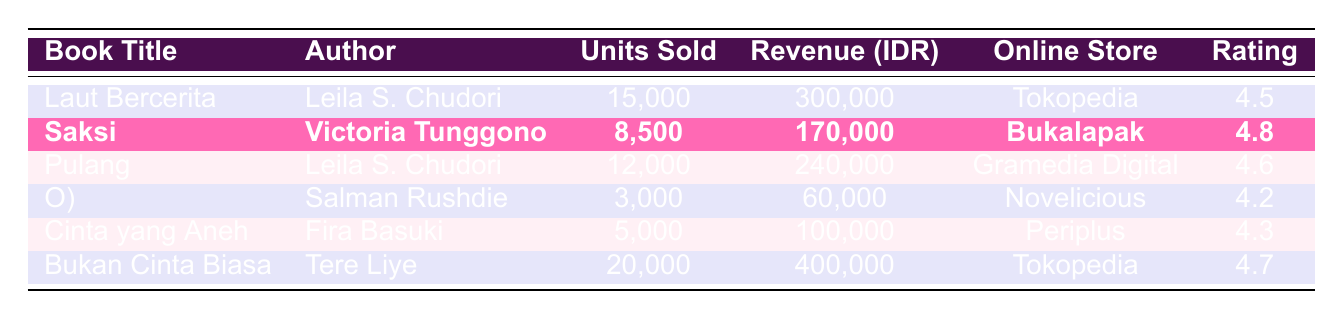What is the total revenue generated from all books listed in the table? To find the total revenue, sum the revenue amounts: 300,000 + 170,000 + 240,000 + 60,000 + 100,000 + 400,000 = 1,360,000.
Answer: 1,360,000 Which book sold the highest number of units? Compare the units sold for each book: Laut Bercerita (15,000), Saksi (8,500), Pulang (12,000), O) (3,000), Cinta yang Aneh (5,000), and Bukan Cinta Biasa (20,000). Bukan Cinta Biasa has the highest units sold at 20,000.
Answer: Bukan Cinta Biasa What is the average rating of the books listed? Calculate the average rating by adding the ratings: (4.5 + 4.8 + 4.6 + 4.2 + 4.3 + 4.7) / 6 = 4.5.
Answer: 4.5 Did Victoria Tunggono's book generate more revenue than Laut Bercerita? Compare the revenue: Laut Bercerita generated 300,000, while Saksi (Victoria Tunggono’s book) generated 170,000. Since 170,000 is less than 300,000, the statement is false.
Answer: No How many units did Leila S. Chudori's books sell in total? Leila S. Chudori has two books: Laut Bercerita (15,000) and Pulang (12,000). Summing these gives 15,000 + 12,000 = 27,000 units.
Answer: 27,000 Which online store had the highest revenue from a single book? The book with the highest revenue is Bukan Cinta Biasa from Tokopedia, which generated 400,000. Compare the revenues from other books in the respective stores to confirm.
Answer: Tokopedia What percentage of total units sold are from Bukan Cinta Biasa? Total units sold are 15,000 + 8,500 + 12,000 + 3,000 + 5,000 + 20,000 = 63,500. Bukan Cinta Biasa sold 20,000 units, so the percentage is (20,000 / 63,500) * 100 ≈ 31.5%.
Answer: 31.5% Which book has the lowest average rating? Looking at the average ratings in the table: Laut Bercerita (4.5), Saksi (4.8), Pulang (4.6), O) (4.2), Cinta yang Aneh (4.3), Bukan Cinta Biasa (4.7). O) has the lowest rating at 4.2.
Answer: O) Is there a book by an author other than Leila S. Chudori that sold more than 10,000 units? Check the units sold: Saksi (8,500), O) (3,000), Cinta yang Aneh (5,000), and Bukan Cinta Biasa (20,000). Bukan Cinta Biasa is by Tere Liye and sold more than 10,000 units. Thus, the answer is true.
Answer: Yes What is the difference in units sold between the best-selling book and the lowest-selling book? The best-selling book is Bukan Cinta Biasa (20,000), and the lowest-selling book is O) (3,000). The difference is 20,000 - 3,000 = 17,000 units.
Answer: 17,000 